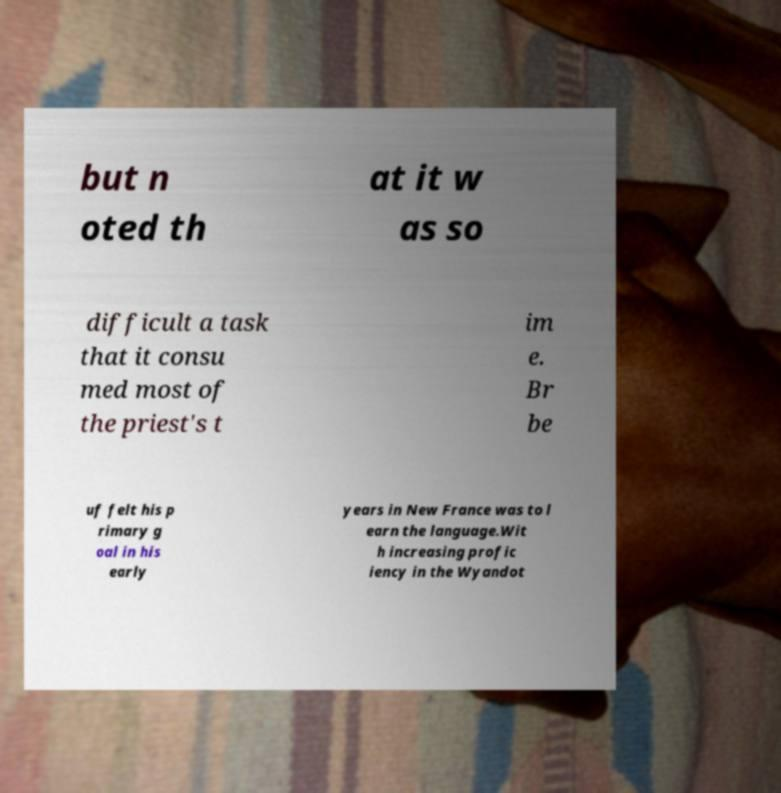Could you extract and type out the text from this image? but n oted th at it w as so difficult a task that it consu med most of the priest's t im e. Br be uf felt his p rimary g oal in his early years in New France was to l earn the language.Wit h increasing profic iency in the Wyandot 